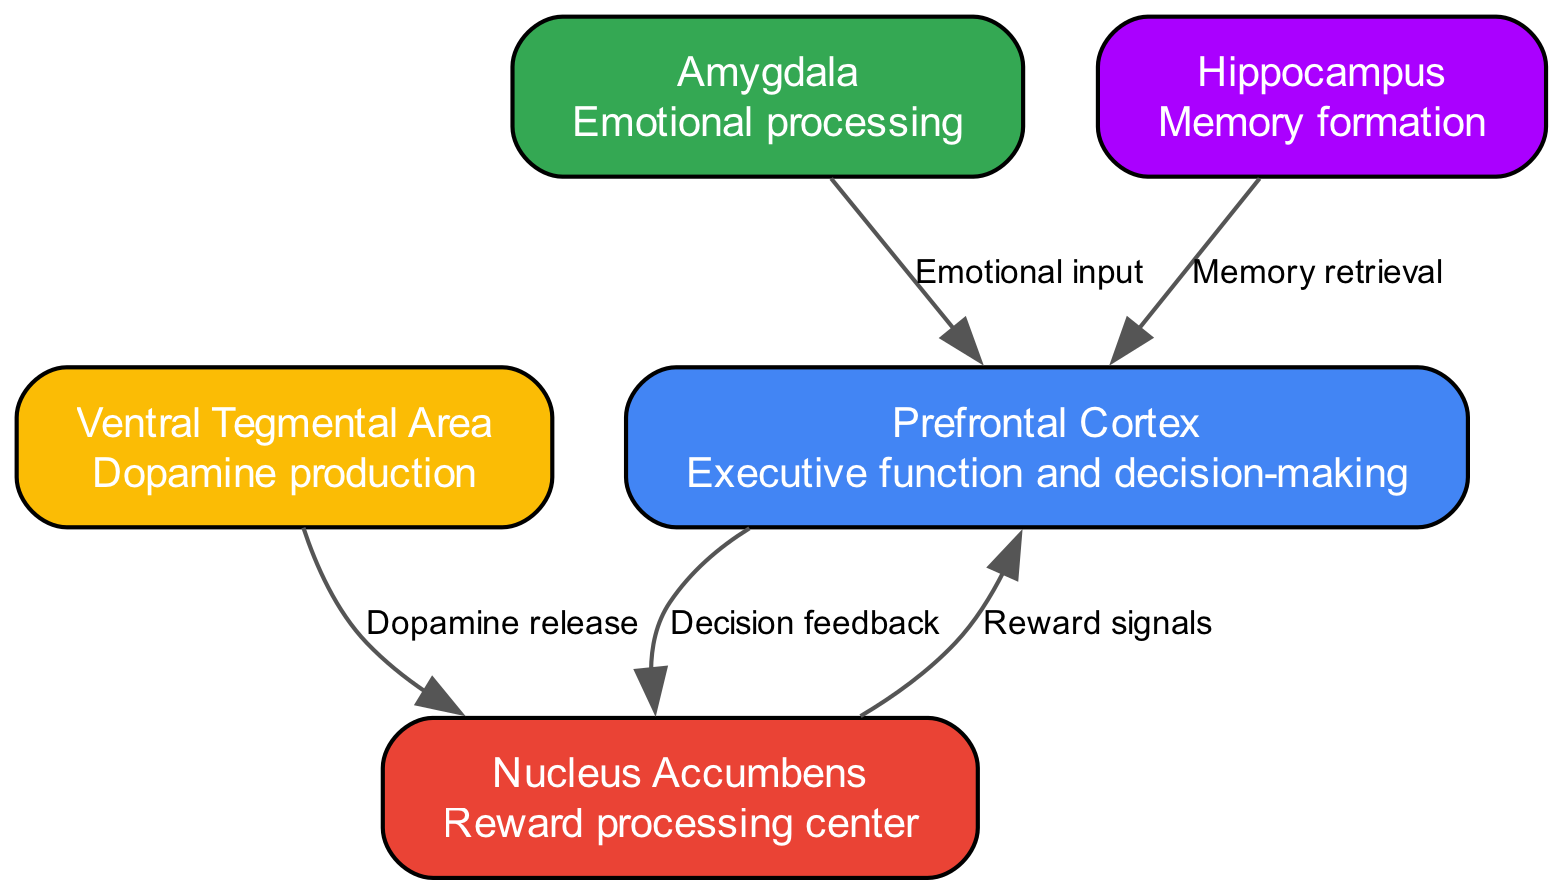What is the role of the Nucleus Accumbens? The Nucleus Accumbens is labeled as the "Reward processing center," highlighting its involvement in processing rewards during social interactions.
Answer: Reward processing center How many nodes are present in the diagram? By counting the nodes listed in the data, there are five distinct nodes representing different brain regions involved in decision-making and reward processing.
Answer: 5 What neurotransmitter is produced in the Ventral Tegmental Area? The Ventral Tegmental Area is associated with dopamine production, as indicated specifically in its description.
Answer: Dopamine Which node provides emotional input to the Prefrontal Cortex? The arrow labeled "Emotional input" connects the Amygdala to the Prefrontal Cortex, indicating that the Amygdala is responsible for providing emotional input in the decision-making process.
Answer: Amygdala What type of signal does the Nucleus Accumbens send to the Prefrontal Cortex? The diagram shows that the Nucleus Accumbens sends "Reward signals" to the Prefrontal Cortex, indicating its role in signaling rewards in decision-making.
Answer: Reward signals What is the relationship between the Hippocampus and the Prefrontal Cortex? The Hippocampus retrieves memories and sends this information to the Prefrontal Cortex, as indicated by the edge labeled "Memory retrieval." This relationship supports decision-making by providing relevant memories.
Answer: Memory retrieval Which brain region is primarily involved in dopamine release? The Ventral Tegmental Area is responsible for dopamine production, which is crucial for activating the reward pathways, as depicted by the direct edge connecting it to the Nucleus Accumbens.
Answer: Ventral Tegmental Area What is the primary function of the Prefrontal Cortex according to the diagram? The description for the Prefrontal Cortex states it is responsible for "Executive function and decision-making," highlighting its role in processing complex behaviors and choices.
Answer: Executive function and decision-making 